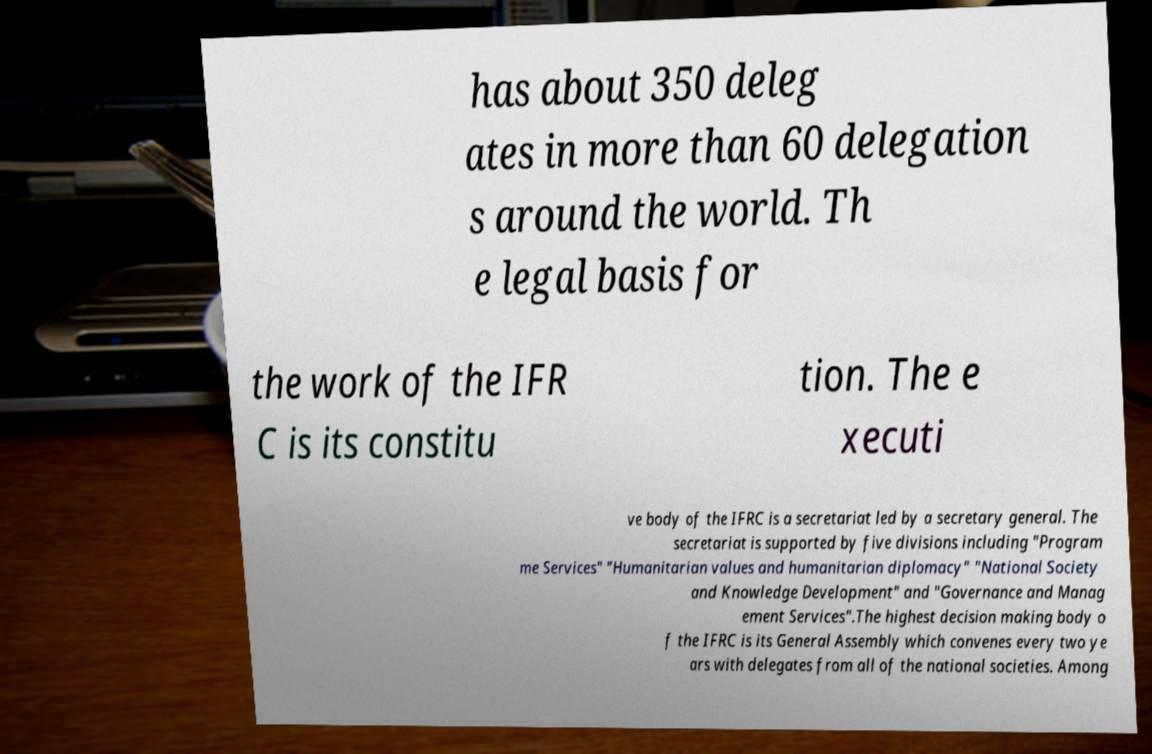Can you read and provide the text displayed in the image?This photo seems to have some interesting text. Can you extract and type it out for me? has about 350 deleg ates in more than 60 delegation s around the world. Th e legal basis for the work of the IFR C is its constitu tion. The e xecuti ve body of the IFRC is a secretariat led by a secretary general. The secretariat is supported by five divisions including "Program me Services" "Humanitarian values and humanitarian diplomacy" "National Society and Knowledge Development" and "Governance and Manag ement Services".The highest decision making body o f the IFRC is its General Assembly which convenes every two ye ars with delegates from all of the national societies. Among 